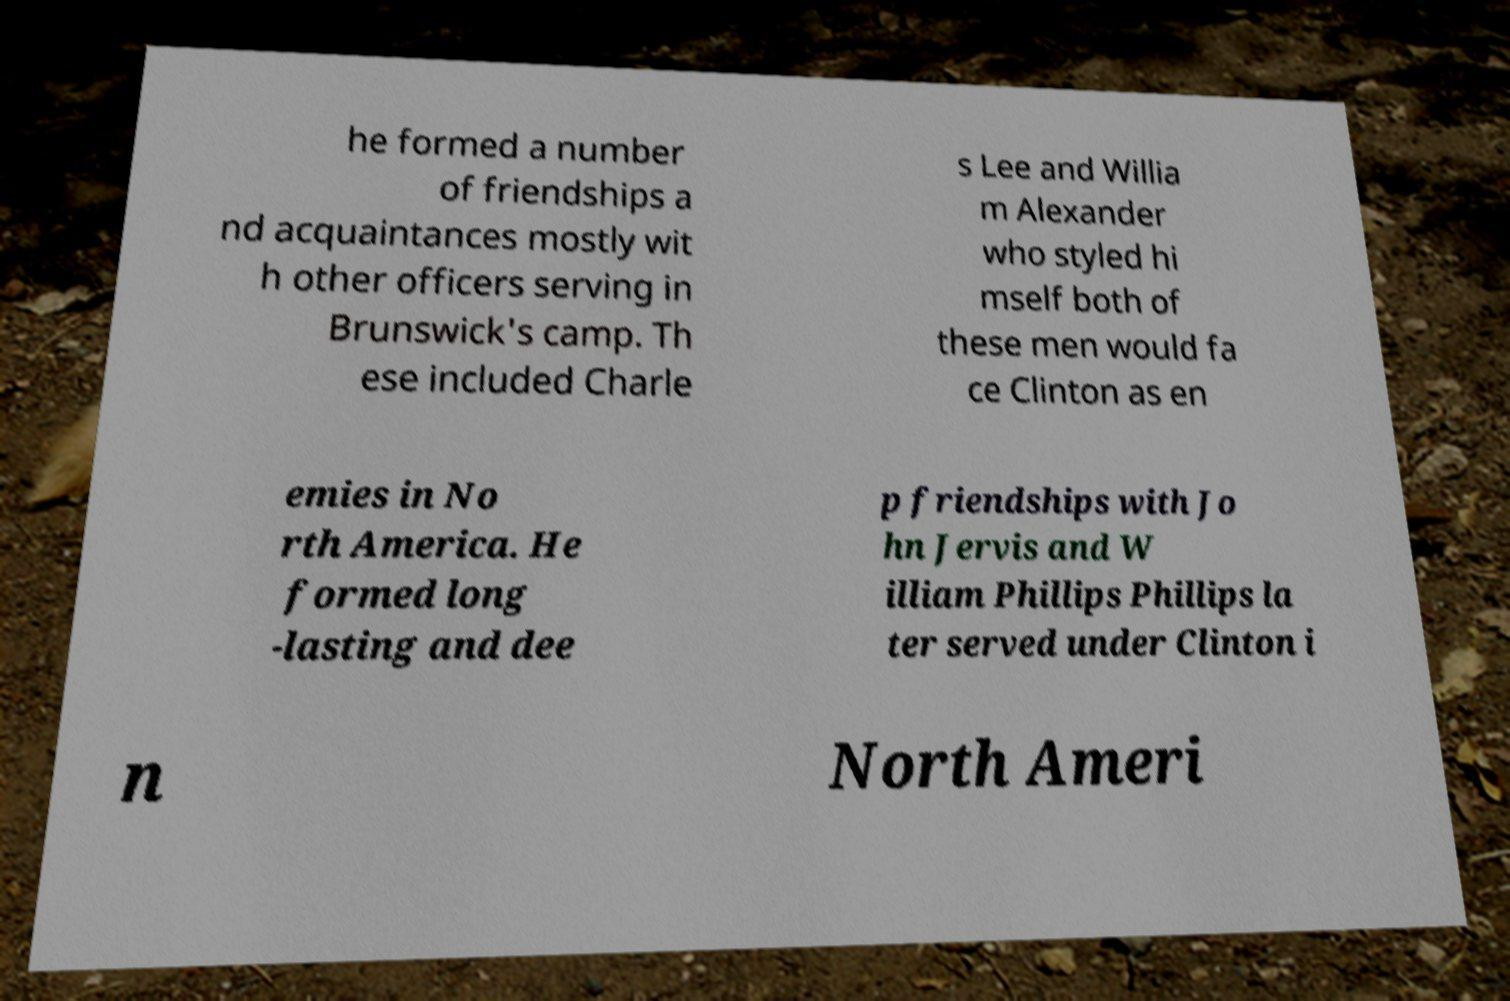Please read and relay the text visible in this image. What does it say? he formed a number of friendships a nd acquaintances mostly wit h other officers serving in Brunswick's camp. Th ese included Charle s Lee and Willia m Alexander who styled hi mself both of these men would fa ce Clinton as en emies in No rth America. He formed long -lasting and dee p friendships with Jo hn Jervis and W illiam Phillips Phillips la ter served under Clinton i n North Ameri 